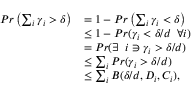<formula> <loc_0><loc_0><loc_500><loc_500>\begin{array} { r l } { P r \left ( \sum _ { i } \gamma _ { i } > \delta \right ) } & { = 1 - P r \left ( \sum _ { i } \gamma _ { i } < \delta \right ) } \\ & { \leq 1 - P r ( \gamma _ { i } < \delta / d \, \forall i ) } \\ & { = P r ( \exists \, i \ni \gamma _ { i } > \delta / d ) } \\ & { \leq \sum _ { i } P r ( \gamma _ { i } > \delta / d ) } \\ & { \leq \sum _ { i } B ( \delta / d , D _ { i } , C _ { i } ) , } \end{array}</formula> 